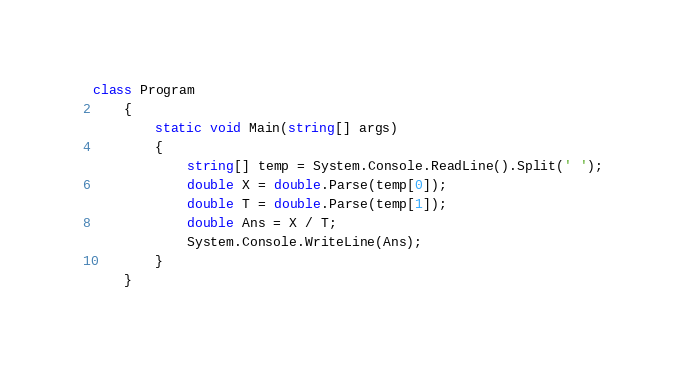Convert code to text. <code><loc_0><loc_0><loc_500><loc_500><_C#_>class Program
    {
        static void Main(string[] args)
        {
            string[] temp = System.Console.ReadLine().Split(' ');
            double X = double.Parse(temp[0]);
            double T = double.Parse(temp[1]);
            double Ans = X / T;
            System.Console.WriteLine(Ans);
        }
    }</code> 